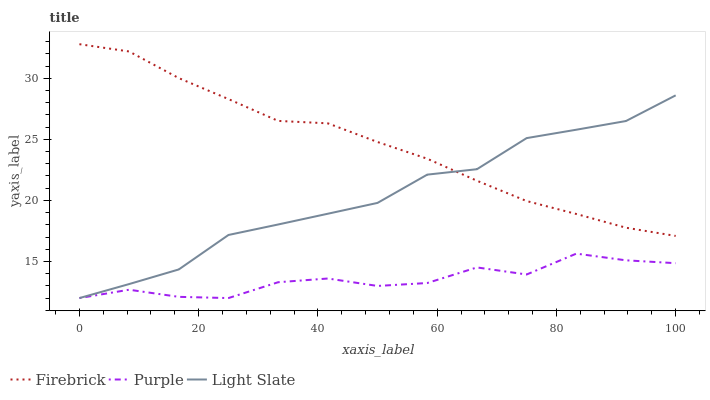Does Purple have the minimum area under the curve?
Answer yes or no. Yes. Does Firebrick have the maximum area under the curve?
Answer yes or no. Yes. Does Light Slate have the minimum area under the curve?
Answer yes or no. No. Does Light Slate have the maximum area under the curve?
Answer yes or no. No. Is Firebrick the smoothest?
Answer yes or no. Yes. Is Purple the roughest?
Answer yes or no. Yes. Is Light Slate the smoothest?
Answer yes or no. No. Is Light Slate the roughest?
Answer yes or no. No. Does Firebrick have the lowest value?
Answer yes or no. No. Does Firebrick have the highest value?
Answer yes or no. Yes. Does Light Slate have the highest value?
Answer yes or no. No. Is Purple less than Firebrick?
Answer yes or no. Yes. Is Firebrick greater than Purple?
Answer yes or no. Yes. Does Firebrick intersect Light Slate?
Answer yes or no. Yes. Is Firebrick less than Light Slate?
Answer yes or no. No. Is Firebrick greater than Light Slate?
Answer yes or no. No. Does Purple intersect Firebrick?
Answer yes or no. No. 